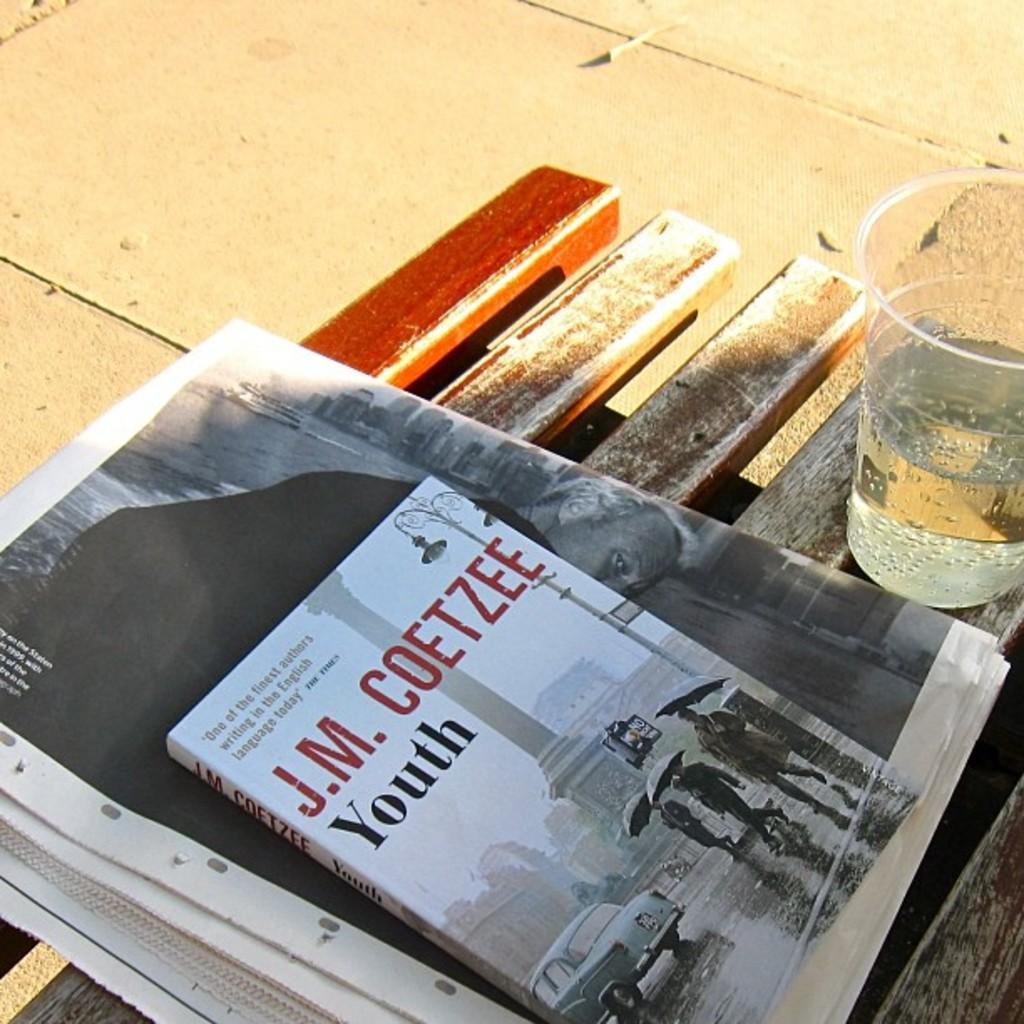Provide a one-sentence caption for the provided image. A J.M. Coetzee book sitting on a bench next to plastic cup. 